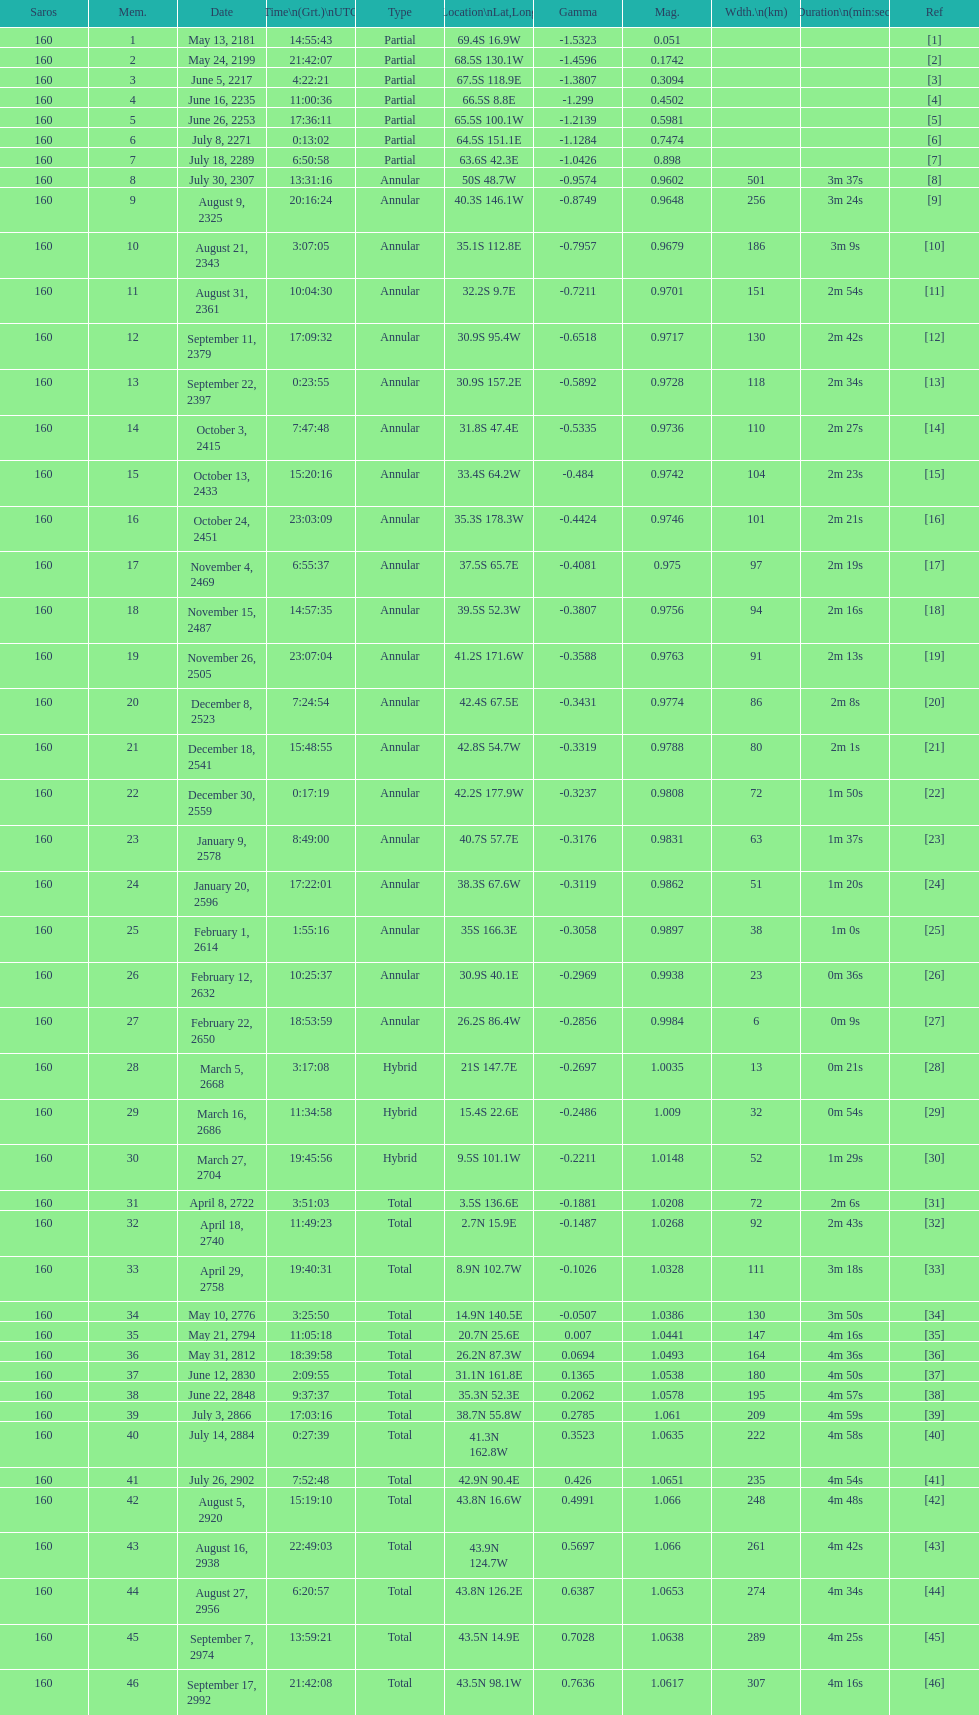What was the duration of 18? 2m 16s. 